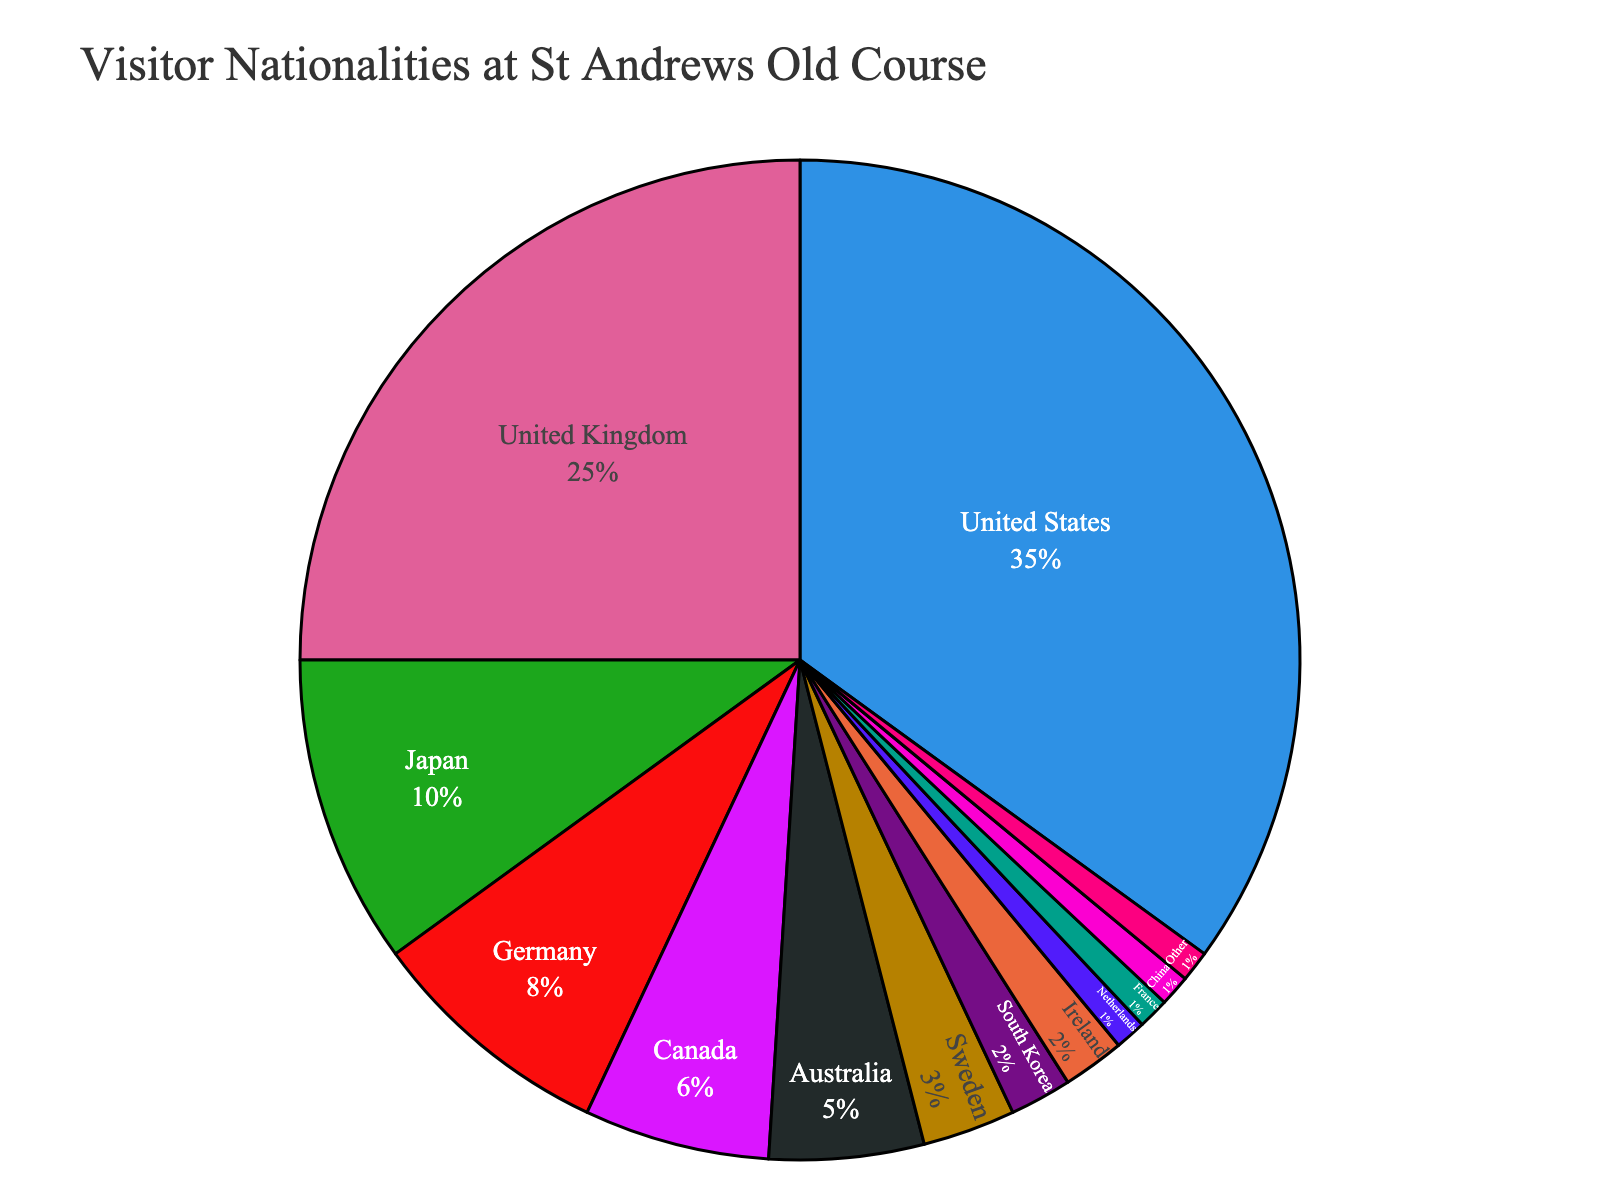Which country contributes the highest percentage of visitors at St Andrews Old Course? The largest slice of the pie chart represents the United States, which indicates the highest percentage of visitors.
Answer: United States What is the combined percentage of visitors from Germany and Canada? To find the combined percentage, add the percentages of visitors from Germany (8%) and Canada (6%). 8% + 6% = 14%
Answer: 14% How does the percentage of visitors from the United Kingdom compare to that from Japan? By inspecting the pie chart, the United Kingdom has a larger slice than Japan. Specifically, the United Kingdom accounts for 25% of visitors, whereas Japan accounts for 10%.
Answer: United Kingdom is greater than Japan Which two countries have the smallest percentages of visitors? The smallest slices of the pie chart represent the Netherlands, France, and China, each contributing 1%. However, given that the "Other" category is also 1%, we focus on the countries, Netherlands and France.
Answer: Netherlands and France What is the percentage difference between visitors from Australia and Sweden? To find the percentage difference, subtract Sweden's percentage (3%) from Australia's percentage (5%). 5% - 3% = 2%
Answer: 2% If you combine visitors from China, South Korea, and Ireland, what percentage of the total does their combined group form? Add the percentages of visitors from South Korea (2%), Ireland (2%), and China (1%). 2% + 2% + 1% = 5%
Answer: 5% By how much does the percentage of visitors from the United States exceed the percentage of visitors from the United Kingdom? Subtract the percentage of visitors from the United Kingdom (25%) from the percentage of visitors from the United States (35%). 35% - 25% = 10%
Answer: 10% What percentage of visitors come from countries other than the top three (United States, United Kingdom, and Japan)? First, sum the percentages of the top three countries: 35% (United States) + 25% (United Kingdom) + 10% (Japan) = 70%. Then, subtract this from 100% to find the percentage from other countries. 100% - 70% = 30%
Answer: 30% What is the color associated with visitors from Canada in the pie chart? Observing the color scheme of the pie chart, the slice for Canada is filled with (provide a color based on actual chart colors). In our hypothetical case, the color might be (light blue, for example).
Answer: (Light blue) [use actual chart color if known] How does the percentage of visitors from Canada compare to the combined percentage of visitors from Sweden and Ireland? By adding the percentages of visitors from Sweden (3%) and Ireland (2%), the total is 5%. This is equal to the percentage of visitors from Canada, which is also 5%.
Answer: Equal 